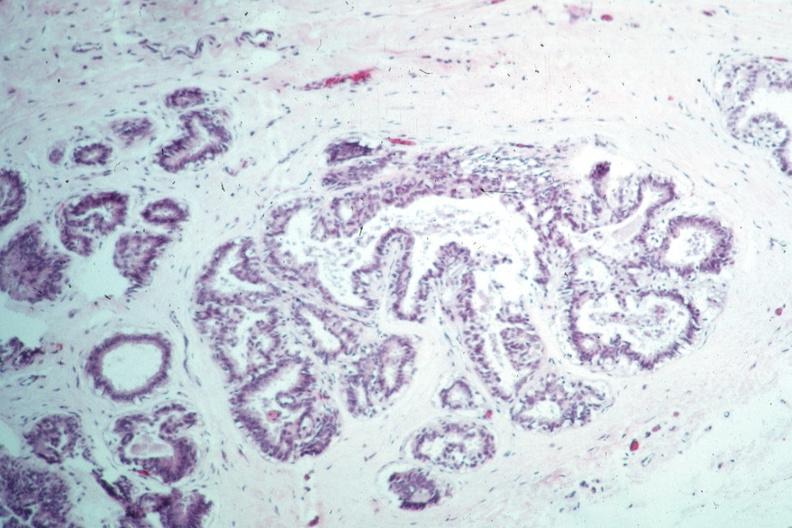s peritoneum present?
Answer the question using a single word or phrase. No 